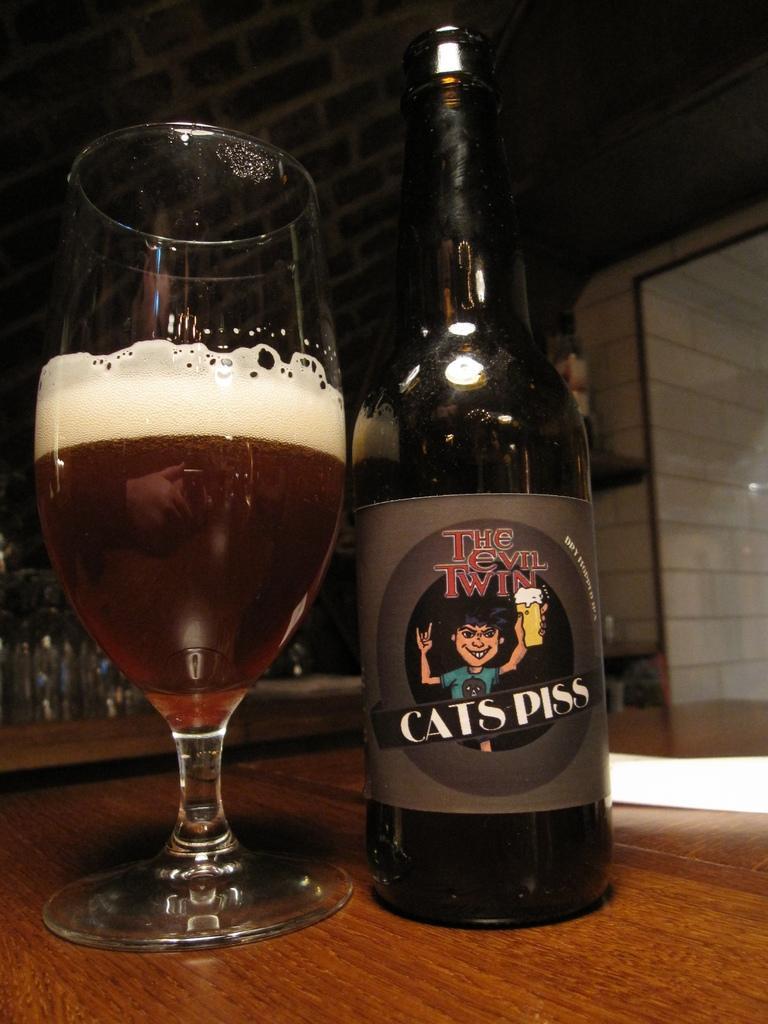How would you summarize this image in a sentence or two? In this picture there is a glass and bottle on the table and there is a picture of a person on the label and there is a reflection of a person on the glass. At the back there are bottles and there is a wall. 